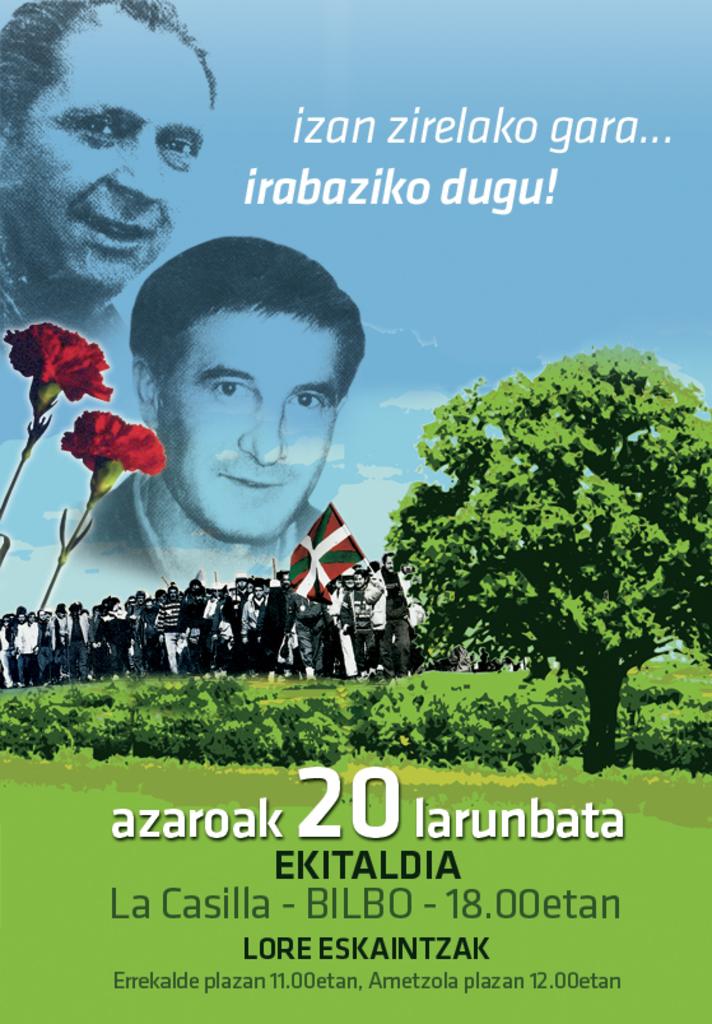At what location is the event being held at 11.00etan?
Keep it short and to the point. Errekalde plazan. What is the tagline for the event?
Make the answer very short. Izan zirelako gara... irabaziko dugu!. 